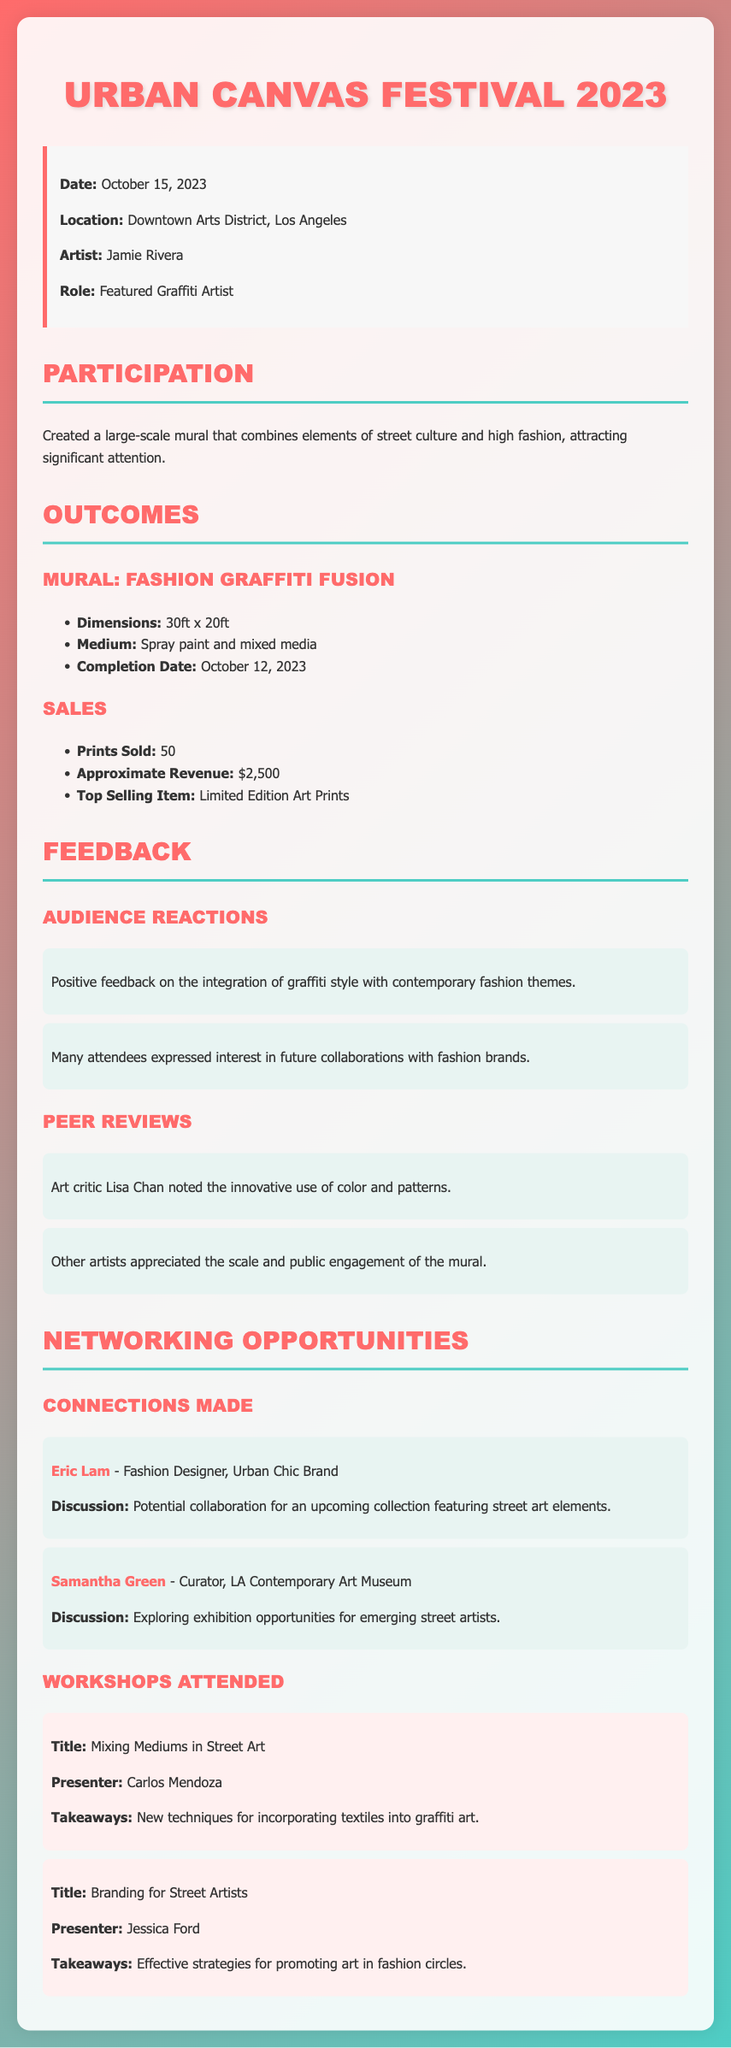what is the date of the festival? The document states that the festival took place on October 15, 2023.
Answer: October 15, 2023 who was the featured graffiti artist? The artist named as the featured graffiti artist in the document is Jamie Rivera.
Answer: Jamie Rivera how many prints were sold? The document mentions that a total of 50 prints were sold during the festival.
Answer: 50 what was the approximate revenue generated? The document specifies that the approximate revenue generated from sales was $2,500.
Answer: $2,500 which fashion brand designer was mentioned for potential collaboration? The document lists Eric Lam as the fashion designer with whom potential collaboration was discussed.
Answer: Eric Lam what technique was learned in the workshop titled "Mixing Mediums in Street Art"? The takeaway from the workshop is that new techniques for incorporating textiles into graffiti art were learned.
Answer: Textiles into graffiti art who provided positive feedback on the mural's innovative use of color? The art critic Lisa Chan is noted for providing feedback on the innovative use of color and patterns in the mural.
Answer: Lisa Chan how large was the mural created for the festival? The document provides the dimensions of the mural as 30 feet by 20 feet.
Answer: 30ft x 20ft what was the top selling item? The top selling item mentioned in the document is the Limited Edition Art Prints.
Answer: Limited Edition Art Prints 